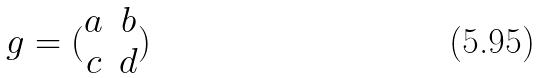Convert formula to latex. <formula><loc_0><loc_0><loc_500><loc_500>g = ( \begin{matrix} a & b \\ c & d \end{matrix} )</formula> 